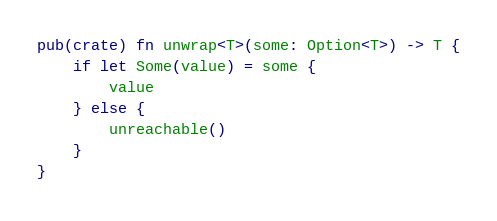<code> <loc_0><loc_0><loc_500><loc_500><_Rust_>pub(crate) fn unwrap<T>(some: Option<T>) -> T {
    if let Some(value) = some {
        value
    } else {
        unreachable()
    }
}
</code> 